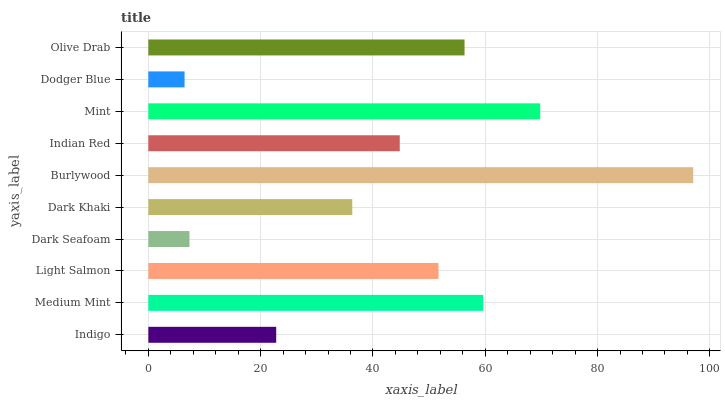Is Dodger Blue the minimum?
Answer yes or no. Yes. Is Burlywood the maximum?
Answer yes or no. Yes. Is Medium Mint the minimum?
Answer yes or no. No. Is Medium Mint the maximum?
Answer yes or no. No. Is Medium Mint greater than Indigo?
Answer yes or no. Yes. Is Indigo less than Medium Mint?
Answer yes or no. Yes. Is Indigo greater than Medium Mint?
Answer yes or no. No. Is Medium Mint less than Indigo?
Answer yes or no. No. Is Light Salmon the high median?
Answer yes or no. Yes. Is Indian Red the low median?
Answer yes or no. Yes. Is Burlywood the high median?
Answer yes or no. No. Is Dark Seafoam the low median?
Answer yes or no. No. 